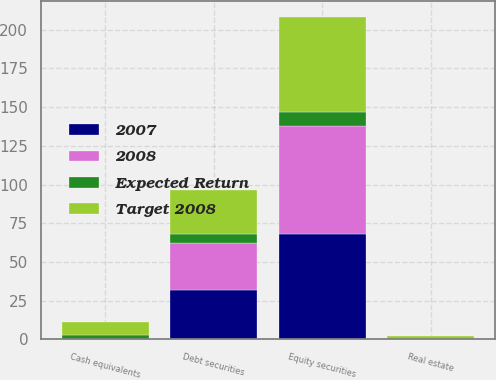<chart> <loc_0><loc_0><loc_500><loc_500><stacked_bar_chart><ecel><fcel>Equity securities<fcel>Debt securities<fcel>Real estate<fcel>Cash equivalents<nl><fcel>Target 2008<fcel>61.1<fcel>29<fcel>2.1<fcel>7.8<nl><fcel>2007<fcel>67.8<fcel>32.1<fcel>0<fcel>0.1<nl><fcel>2008<fcel>70<fcel>30<fcel>0<fcel>0<nl><fcel>Expected Return<fcel>9<fcel>5.7<fcel>0<fcel>3.1<nl></chart> 